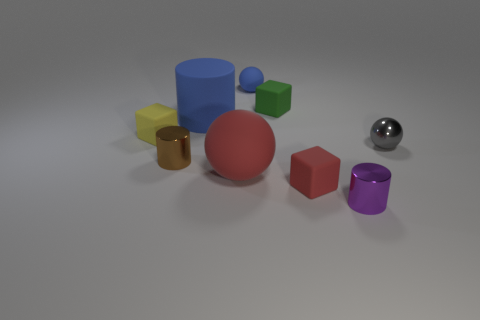Can you describe the colors and shapes present in the image? Certainly! The image features a collection of geometric shapes in various colors. There's a large blue cylinder, a gold-colored cube, a small red cube, a purple cylinder, a small green cube, and a shiny silver sphere. The arrangement of these shapes on a neutral background creates a visually pleasing contrast. 